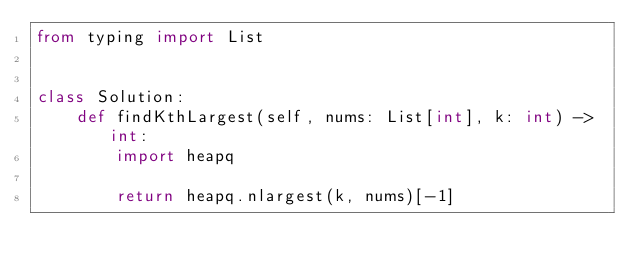<code> <loc_0><loc_0><loc_500><loc_500><_Python_>from typing import List


class Solution:
    def findKthLargest(self, nums: List[int], k: int) -> int:
        import heapq

        return heapq.nlargest(k, nums)[-1]
</code> 